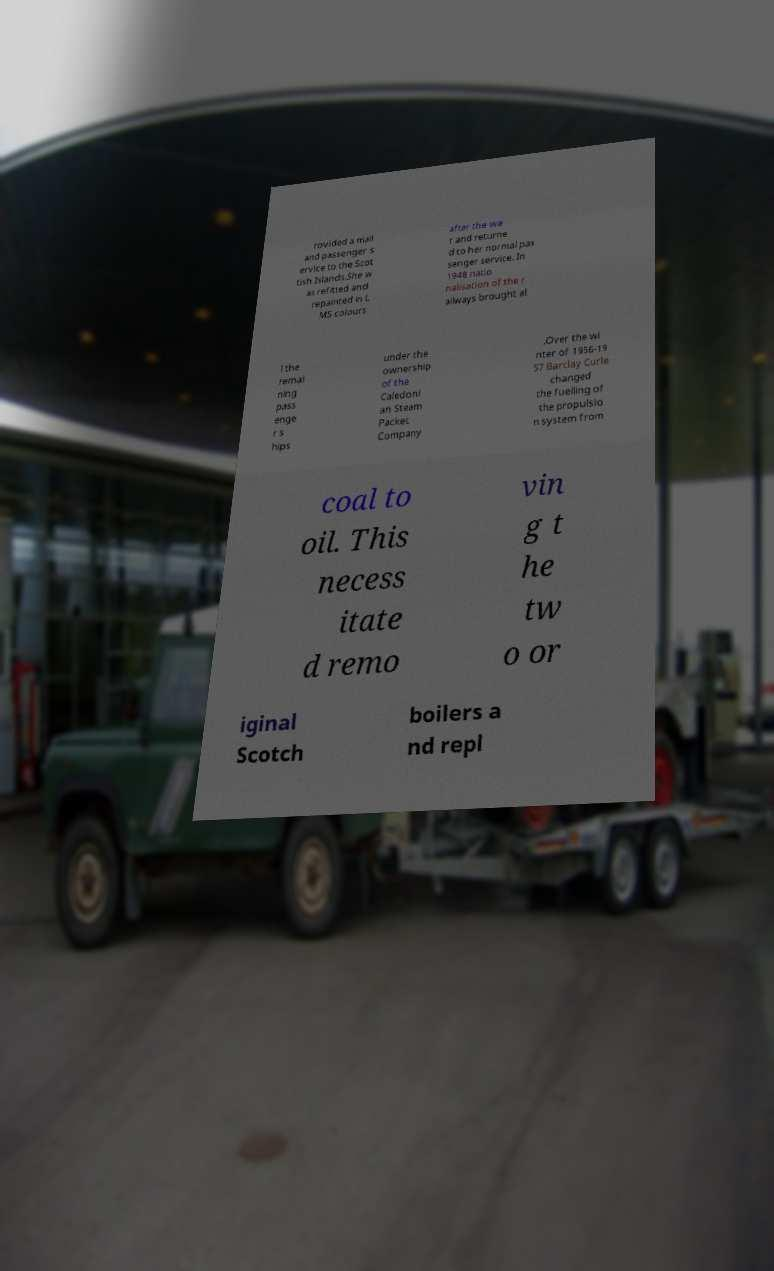I need the written content from this picture converted into text. Can you do that? rovided a mail and passenger s ervice to the Scot tish Islands.She w as refitted and repainted in L MS colours after the wa r and returne d to her normal pas senger service. In 1948 natio nalisation of the r ailways brought al l the remai ning pass enge r s hips under the ownership of the Caledoni an Steam Packet Company .Over the wi nter of 1956-19 57 Barclay Curle changed the fuelling of the propulsio n system from coal to oil. This necess itate d remo vin g t he tw o or iginal Scotch boilers a nd repl 